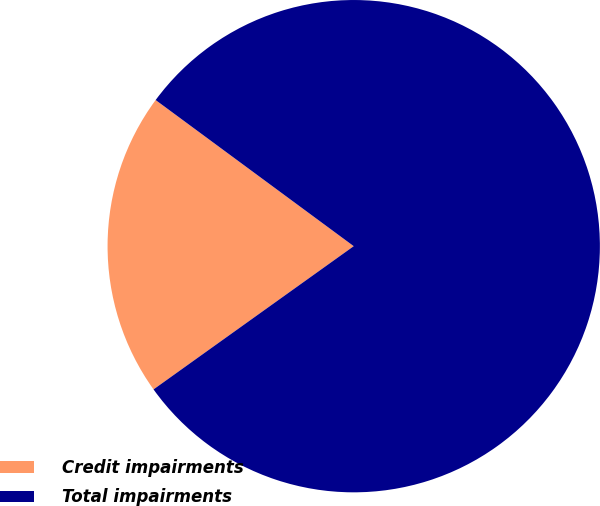Convert chart. <chart><loc_0><loc_0><loc_500><loc_500><pie_chart><fcel>Credit impairments<fcel>Total impairments<nl><fcel>20.0%<fcel>80.0%<nl></chart> 